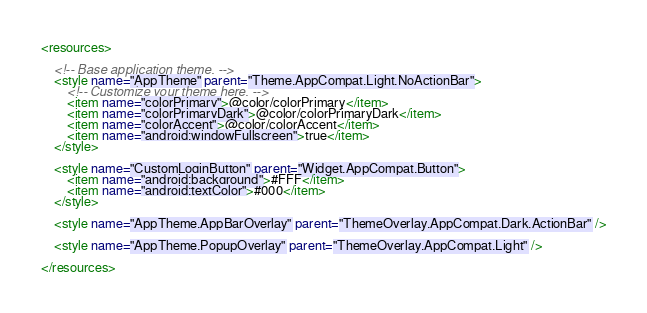Convert code to text. <code><loc_0><loc_0><loc_500><loc_500><_XML_><resources>

    <!-- Base application theme. -->
    <style name="AppTheme" parent="Theme.AppCompat.Light.NoActionBar">
        <!-- Customize your theme here. -->
        <item name="colorPrimary">@color/colorPrimary</item>
        <item name="colorPrimaryDark">@color/colorPrimaryDark</item>
        <item name="colorAccent">@color/colorAccent</item>
        <item name="android:windowFullscreen">true</item>
    </style>

    <style name="CustomLoginButton" parent="Widget.AppCompat.Button">
        <item name="android:background">#FFF</item>
        <item name="android:textColor">#000</item>
    </style>

    <style name="AppTheme.AppBarOverlay" parent="ThemeOverlay.AppCompat.Dark.ActionBar" />

    <style name="AppTheme.PopupOverlay" parent="ThemeOverlay.AppCompat.Light" />

</resources>
</code> 